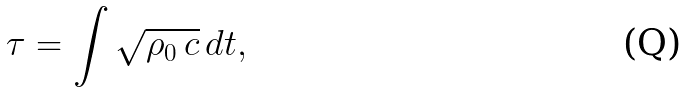Convert formula to latex. <formula><loc_0><loc_0><loc_500><loc_500>\tau = \int \sqrt { \rho _ { 0 } \, c } \, d t ,</formula> 